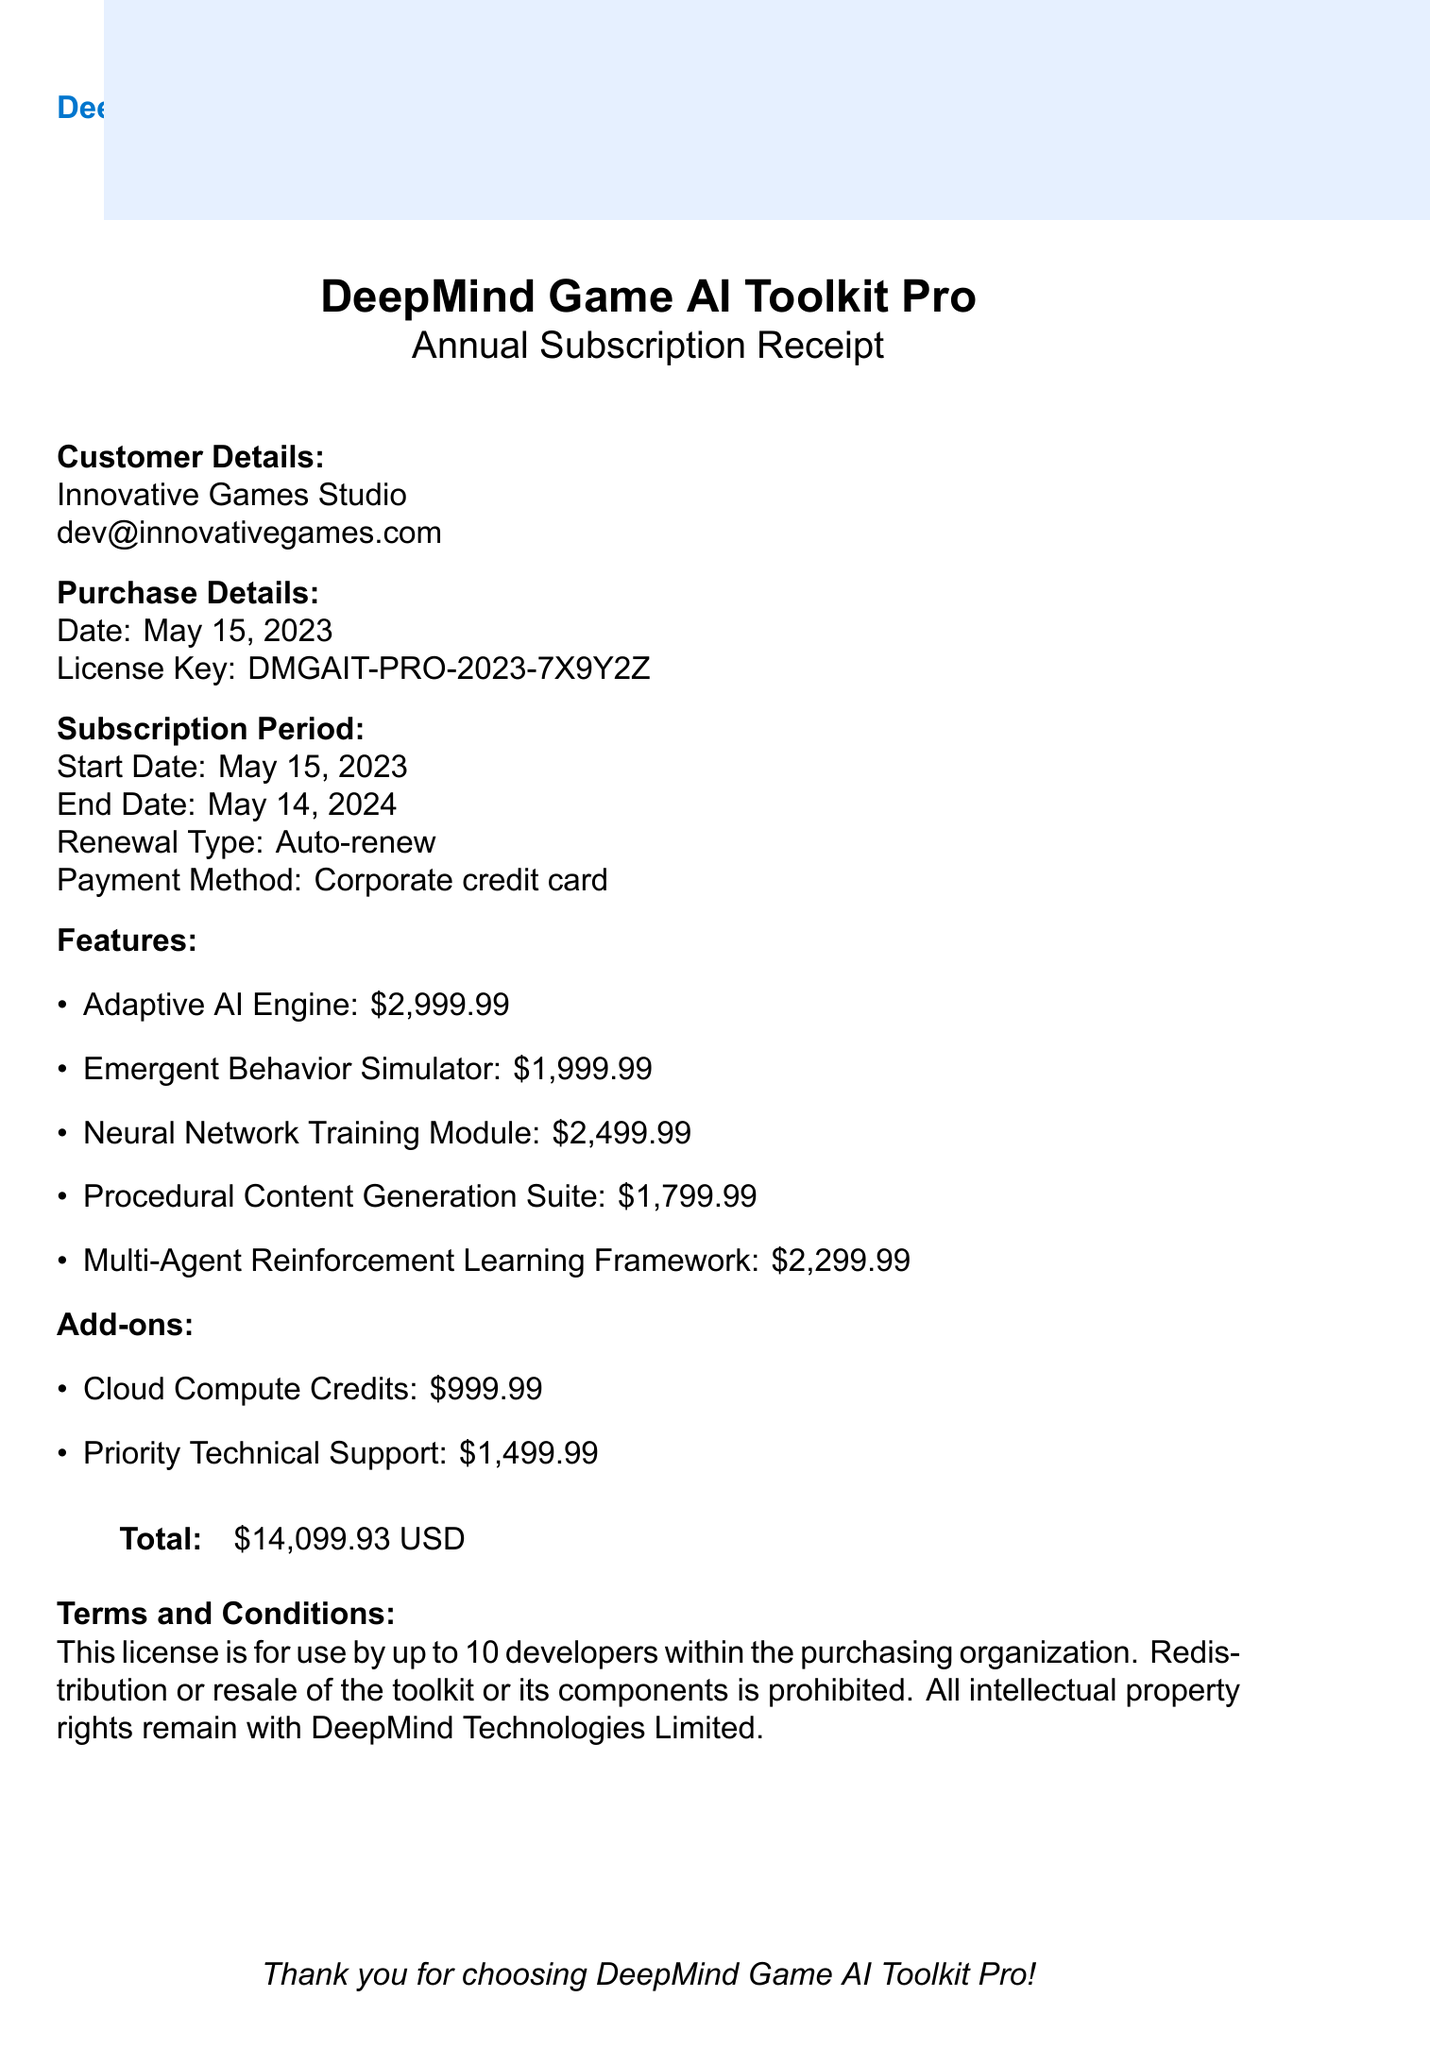What is the company name? The company name is listed at the top of the document as the provider of the software toolkit.
Answer: DeepMind Technologies Limited What is the product name? The product name is presented prominently on the receipt in the title.
Answer: DeepMind Game AI Toolkit Pro What is the purchase date? The purchase date is specified in the purchase details section of the receipt.
Answer: May 15, 2023 What is the total price? The total price is shown at the bottom of the receipt in a tabular format.
Answer: $14,099.93 USD What is the license key? The license key is provided in the purchase details section of the document.
Answer: DMGAIT-PRO-2023-7X9Y2Z How many developers can use the license? The terms and conditions state the number of developers allowed to use the license.
Answer: Up to 10 developers What type of subscription is purchased? The type of subscription is mentioned in the title of the receipt and the subscription details section.
Answer: Annual Subscription What is the end date of the subscription? The end date is stated explicitly in the subscription period section.
Answer: May 14, 2024 What add-on provides 1000 hours of cloud computing? The add-ons section lists the available add-ons with their descriptions, including cloud computing hours.
Answer: Cloud Compute Credits 